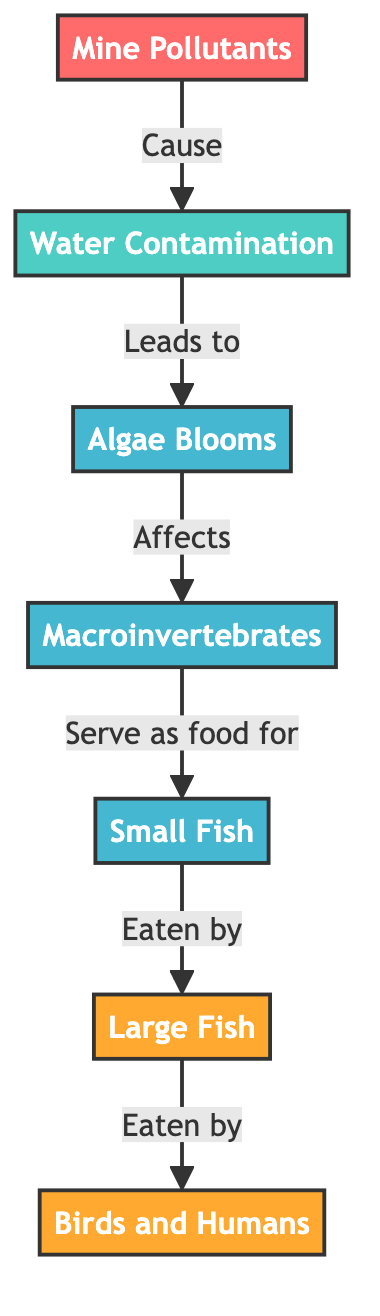What is the first node in the diagram? The first node is "Mine Pollutants," which is the source of the entire flow and represents contaminants introduced by mining activities.
Answer: Mine Pollutants How many organisms are present in the food chain? There are three organisms in the food chain: "Algae Blooms," "Macroinvertebrates," and "Small Fish." Each of these serves as a vital part of the ecosystem, showing the impact on the aquatic food chain.
Answer: 3 What is the last consumer in the diagram? The last consumer in the diagram is "Birds and Humans," which signifies the endpoint of the food chain where pollutants can eventually affect higher trophic levels including predators and humans.
Answer: Birds and Humans Which organism is affected by algae blooms? The organism affected by algae blooms is "Macroinvertebrates;" they are directly impacted by the changes in water quality caused by algae overgrowth.
Answer: Macroinvertebrates What do small fish eat? Small fish eat "Macroinvertebrates," indicating their role as a consumer within the food chain that relies on lower trophic levels for sustenance.
Answer: Macroinvertebrates How do mine pollutants influence the food chain? Mine pollutants lead to "Water Contamination," which starts the chain reaction affecting various organisms and their roles in the food web by altering their environments and food sources.
Answer: Water Contamination What directly leads to algae blooms? "Water Contamination" directly leads to "Algae Blooms," showing the pathway of impact that pollution has on aquatic ecosystems.
Answer: Water Contamination 